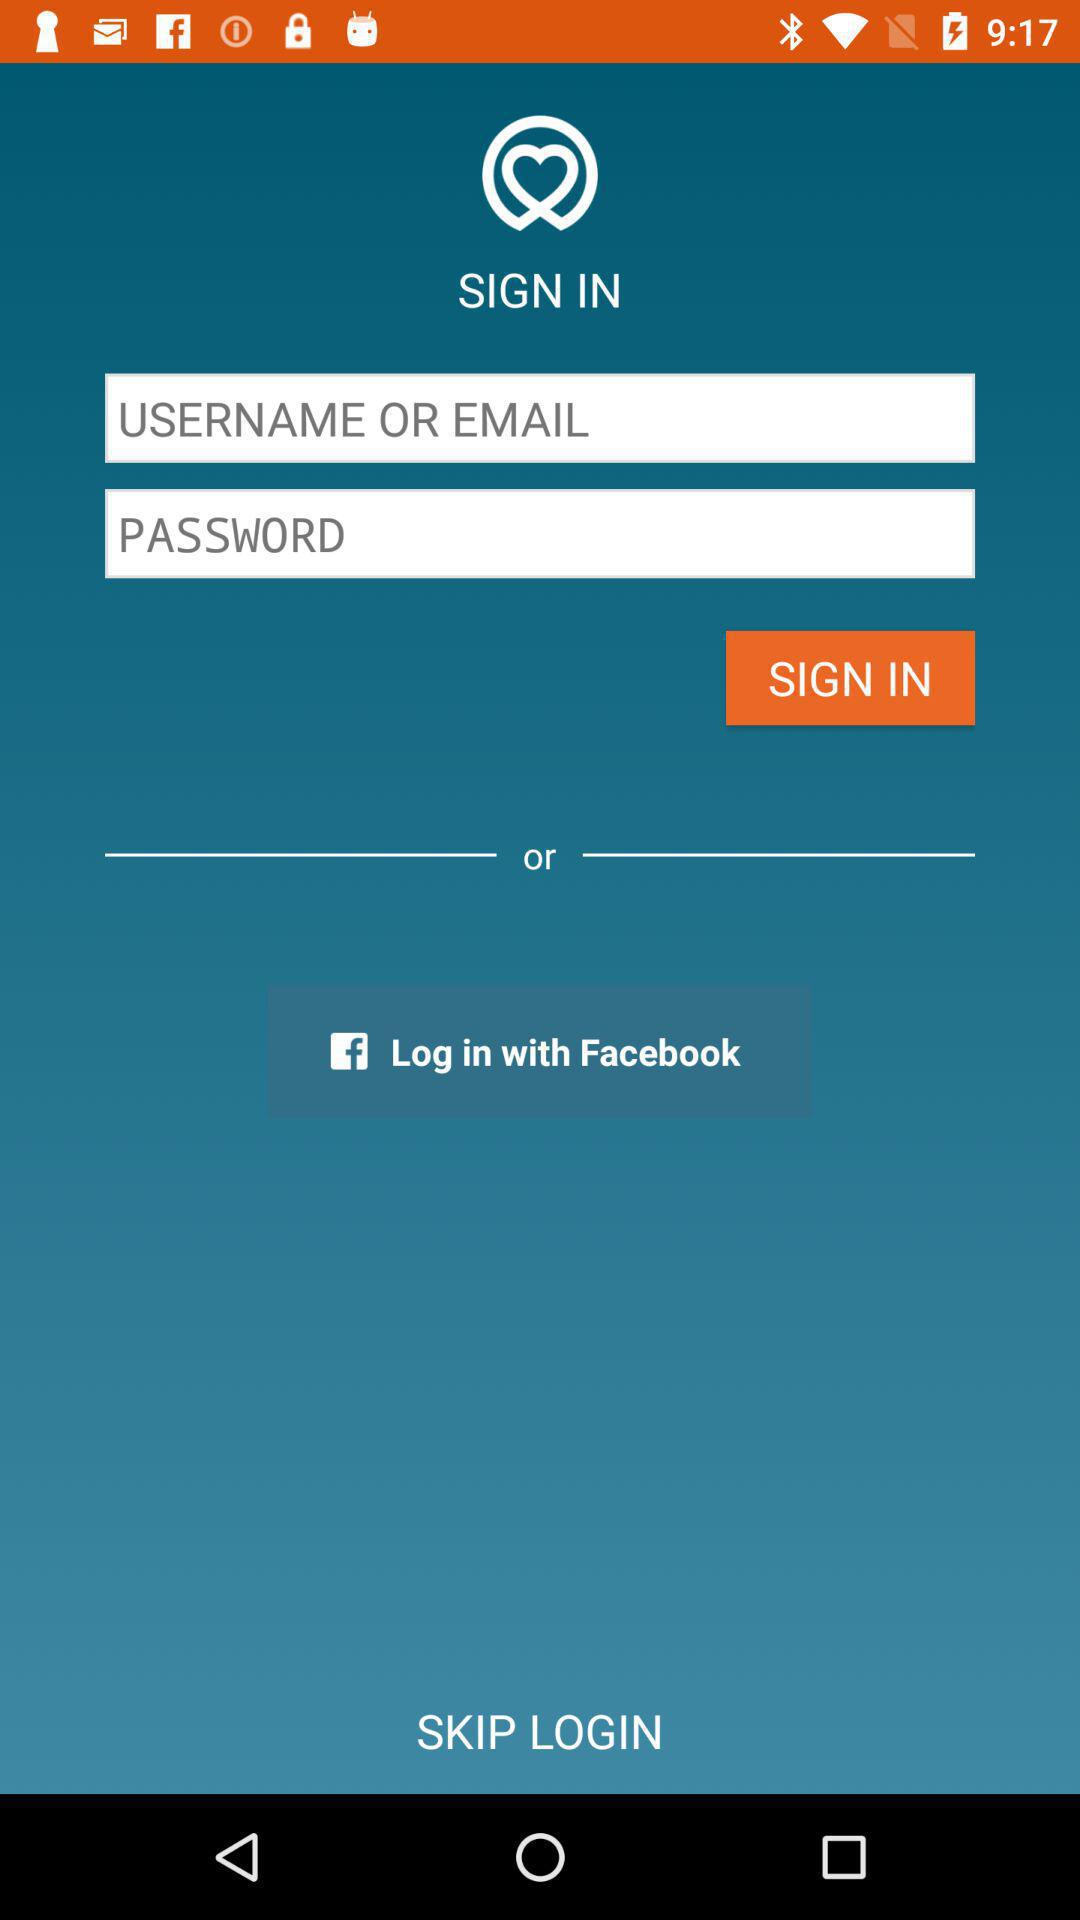Through what application can we log in? You can log in through "Facebook". 